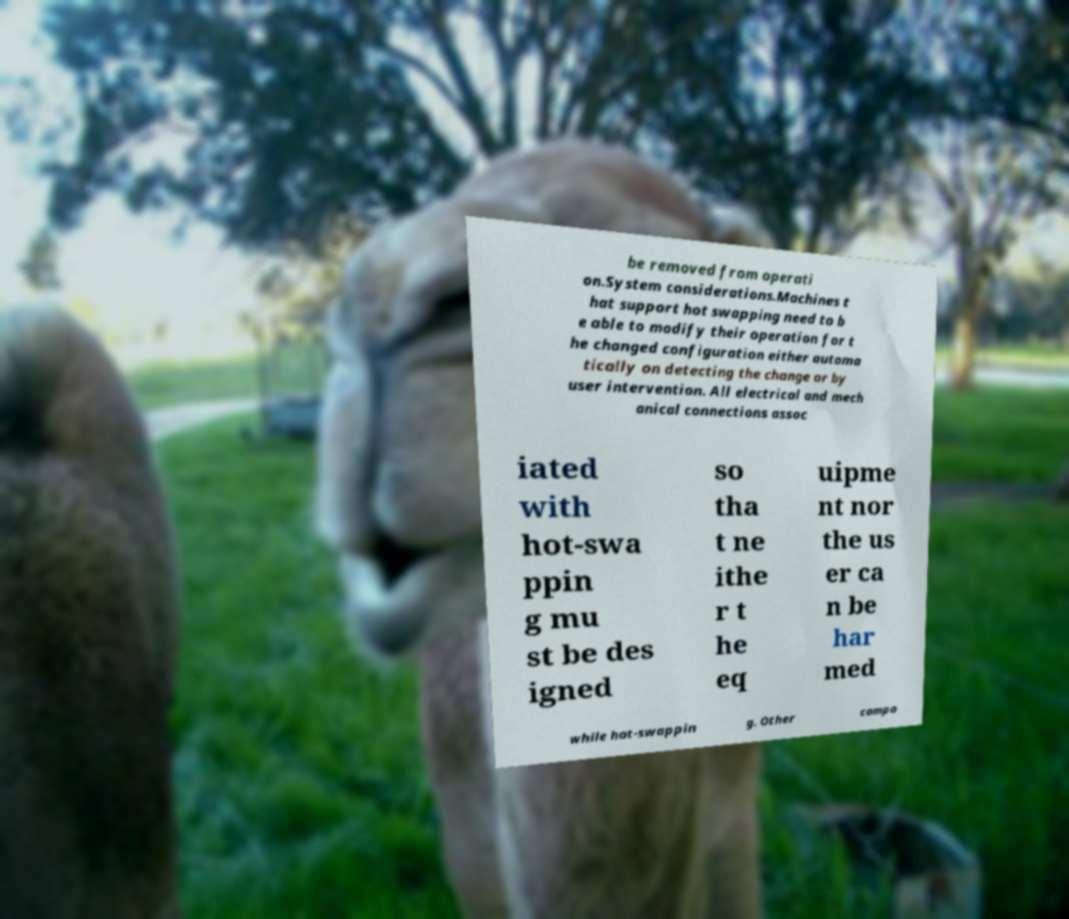Please identify and transcribe the text found in this image. be removed from operati on.System considerations.Machines t hat support hot swapping need to b e able to modify their operation for t he changed configuration either automa tically on detecting the change or by user intervention. All electrical and mech anical connections assoc iated with hot-swa ppin g mu st be des igned so tha t ne ithe r t he eq uipme nt nor the us er ca n be har med while hot-swappin g. Other compo 